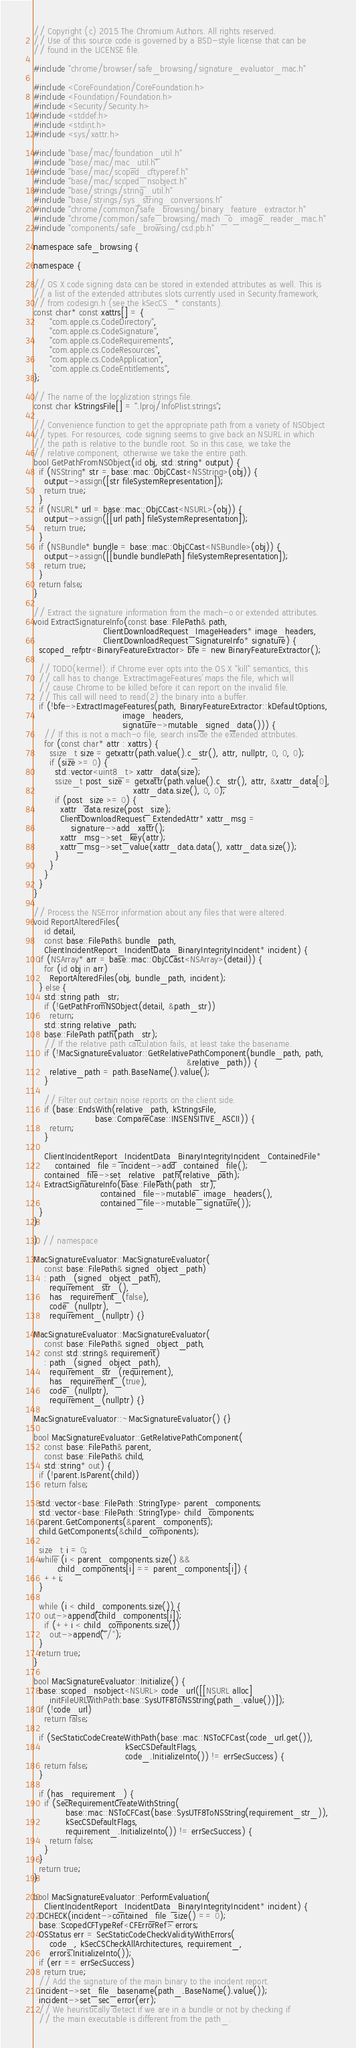<code> <loc_0><loc_0><loc_500><loc_500><_ObjectiveC_>// Copyright (c) 2015 The Chromium Authors. All rights reserved.
// Use of this source code is governed by a BSD-style license that can be
// found in the LICENSE file.

#include "chrome/browser/safe_browsing/signature_evaluator_mac.h"

#include <CoreFoundation/CoreFoundation.h>
#include <Foundation/Foundation.h>
#include <Security/Security.h>
#include <stddef.h>
#include <stdint.h>
#include <sys/xattr.h>

#include "base/mac/foundation_util.h"
#include "base/mac/mac_util.h"
#include "base/mac/scoped_cftyperef.h"
#include "base/mac/scoped_nsobject.h"
#include "base/strings/string_util.h"
#include "base/strings/sys_string_conversions.h"
#include "chrome/common/safe_browsing/binary_feature_extractor.h"
#include "chrome/common/safe_browsing/mach_o_image_reader_mac.h"
#include "components/safe_browsing/csd.pb.h"

namespace safe_browsing {

namespace {

// OS X code signing data can be stored in extended attributes as well. This is
// a list of the extended attributes slots currently used in Security.framework,
// from codesign.h (see the kSecCS_* constants).
const char* const xattrs[] = {
      "com.apple.cs.CodeDirectory",
      "com.apple.cs.CodeSignature",
      "com.apple.cs.CodeRequirements",
      "com.apple.cs.CodeResources",
      "com.apple.cs.CodeApplication",
      "com.apple.cs.CodeEntitlements",
};

// The name of the localization strings file.
const char kStringsFile[] = ".lproj/InfoPlist.strings";

// Convenience function to get the appropriate path from a variety of NSObject
// types. For resources, code signing seems to give back an NSURL in which
// the path is relative to the bundle root. So in this case, we take the
// relative component, otherwise we take the entire path.
bool GetPathFromNSObject(id obj, std::string* output) {
  if (NSString* str = base::mac::ObjCCast<NSString>(obj)) {
    output->assign([str fileSystemRepresentation]);
    return true;
  }
  if (NSURL* url = base::mac::ObjCCast<NSURL>(obj)) {
    output->assign([[url path] fileSystemRepresentation]);
    return true;
  }
  if (NSBundle* bundle = base::mac::ObjCCast<NSBundle>(obj)) {
    output->assign([[bundle bundlePath] fileSystemRepresentation]);
    return true;
  }
  return false;
}

// Extract the signature information from the mach-o or extended attributes.
void ExtractSignatureInfo(const base::FilePath& path,
                          ClientDownloadRequest_ImageHeaders* image_headers,
                          ClientDownloadRequest_SignatureInfo* signature) {
  scoped_refptr<BinaryFeatureExtractor> bfe = new BinaryFeatureExtractor();

  // TODO(kerrnel): if Chrome ever opts into the OS X "kill" semantics, this
  // call has to change. `ExtractImageFeatures` maps the file, which will
  // cause Chrome to be killed before it can report on the invalid file.
  // This call will need to read(2) the binary into a buffer.
  if (!bfe->ExtractImageFeatures(path, BinaryFeatureExtractor::kDefaultOptions,
                                 image_headers,
                                 signature->mutable_signed_data())) {
    // If this is not a mach-o file, search inside the extended attributes.
    for (const char* attr : xattrs) {
      ssize_t size = getxattr(path.value().c_str(), attr, nullptr, 0, 0, 0);
      if (size >= 0) {
        std::vector<uint8_t> xattr_data(size);
        ssize_t post_size = getxattr(path.value().c_str(), attr, &xattr_data[0],
                                     xattr_data.size(), 0, 0);
        if (post_size >= 0) {
          xattr_data.resize(post_size);
          ClientDownloadRequest_ExtendedAttr* xattr_msg =
              signature->add_xattr();
          xattr_msg->set_key(attr);
          xattr_msg->set_value(xattr_data.data(), xattr_data.size());
        }
      }
    }
  }
}

// Process the NSError information about any files that were altered.
void ReportAlteredFiles(
    id detail,
    const base::FilePath& bundle_path,
    ClientIncidentReport_IncidentData_BinaryIntegrityIncident* incident) {
  if (NSArray* arr = base::mac::ObjCCast<NSArray>(detail)) {
    for (id obj in arr)
      ReportAlteredFiles(obj, bundle_path, incident);
  } else {
    std::string path_str;
    if (!GetPathFromNSObject(detail, &path_str))
      return;
    std::string relative_path;
    base::FilePath path(path_str);
    // If the relative path calculation fails, at least take the basename.
    if (!MacSignatureEvaluator::GetRelativePathComponent(bundle_path, path,
                                                         &relative_path)) {
      relative_path = path.BaseName().value();
    }

    // Filter out certain noise reports on the client side.
    if (base::EndsWith(relative_path, kStringsFile,
                       base::CompareCase::INSENSITIVE_ASCII)) {
      return;
    }

    ClientIncidentReport_IncidentData_BinaryIntegrityIncident_ContainedFile*
        contained_file = incident->add_contained_file();
    contained_file->set_relative_path(relative_path);
    ExtractSignatureInfo(base::FilePath(path_str),
                         contained_file->mutable_image_headers(),
                         contained_file->mutable_signature());
  }
}

}  // namespace

MacSignatureEvaluator::MacSignatureEvaluator(
    const base::FilePath& signed_object_path)
    : path_(signed_object_path),
      requirement_str_(),
      has_requirement_(false),
      code_(nullptr),
      requirement_(nullptr) {}

MacSignatureEvaluator::MacSignatureEvaluator(
    const base::FilePath& signed_object_path,
    const std::string& requirement)
    : path_(signed_object_path),
      requirement_str_(requirement),
      has_requirement_(true),
      code_(nullptr),
      requirement_(nullptr) {}

MacSignatureEvaluator::~MacSignatureEvaluator() {}

bool MacSignatureEvaluator::GetRelativePathComponent(
    const base::FilePath& parent,
    const base::FilePath& child,
    std::string* out) {
  if (!parent.IsParent(child))
    return false;

  std::vector<base::FilePath::StringType> parent_components;
  std::vector<base::FilePath::StringType> child_components;
  parent.GetComponents(&parent_components);
  child.GetComponents(&child_components);

  size_t i = 0;
  while (i < parent_components.size() &&
         child_components[i] == parent_components[i]) {
    ++i;
  }

  while (i < child_components.size()) {
    out->append(child_components[i]);
    if (++i < child_components.size())
      out->append("/");
  }
  return true;
}

bool MacSignatureEvaluator::Initialize() {
  base::scoped_nsobject<NSURL> code_url([[NSURL alloc]
      initFileURLWithPath:base::SysUTF8ToNSString(path_.value())]);
  if (!code_url)
    return false;

  if (SecStaticCodeCreateWithPath(base::mac::NSToCFCast(code_url.get()),
                                  kSecCSDefaultFlags,
                                  code_.InitializeInto()) != errSecSuccess) {
    return false;
  }

  if (has_requirement_) {
    if (SecRequirementCreateWithString(
            base::mac::NSToCFCast(base::SysUTF8ToNSString(requirement_str_)),
            kSecCSDefaultFlags,
            requirement_.InitializeInto()) != errSecSuccess) {
      return false;
    }
  }
  return true;
}

bool MacSignatureEvaluator::PerformEvaluation(
    ClientIncidentReport_IncidentData_BinaryIntegrityIncident* incident) {
  DCHECK(incident->contained_file_size() == 0);
  base::ScopedCFTypeRef<CFErrorRef> errors;
  OSStatus err = SecStaticCodeCheckValidityWithErrors(
      code_, kSecCSCheckAllArchitectures, requirement_,
      errors.InitializeInto());
  if (err == errSecSuccess)
    return true;
  // Add the signature of the main binary to the incident report.
  incident->set_file_basename(path_.BaseName().value());
  incident->set_sec_error(err);
  // We heuristically detect if we are in a bundle or not by checking if
  // the main executable is different from the path_.</code> 